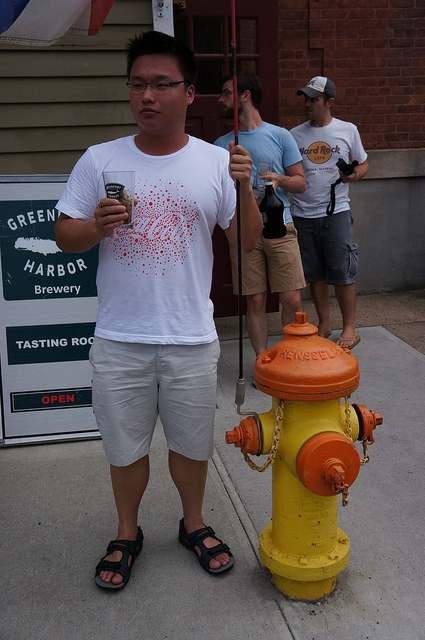Describe the objects in this image and their specific colors. I can see people in navy, gray, maroon, darkgray, and black tones, fire hydrant in navy, olive, and maroon tones, people in navy, black, gray, darkgray, and maroon tones, people in navy, maroon, black, and gray tones, and bottle in navy, black, gray, and darkgray tones in this image. 